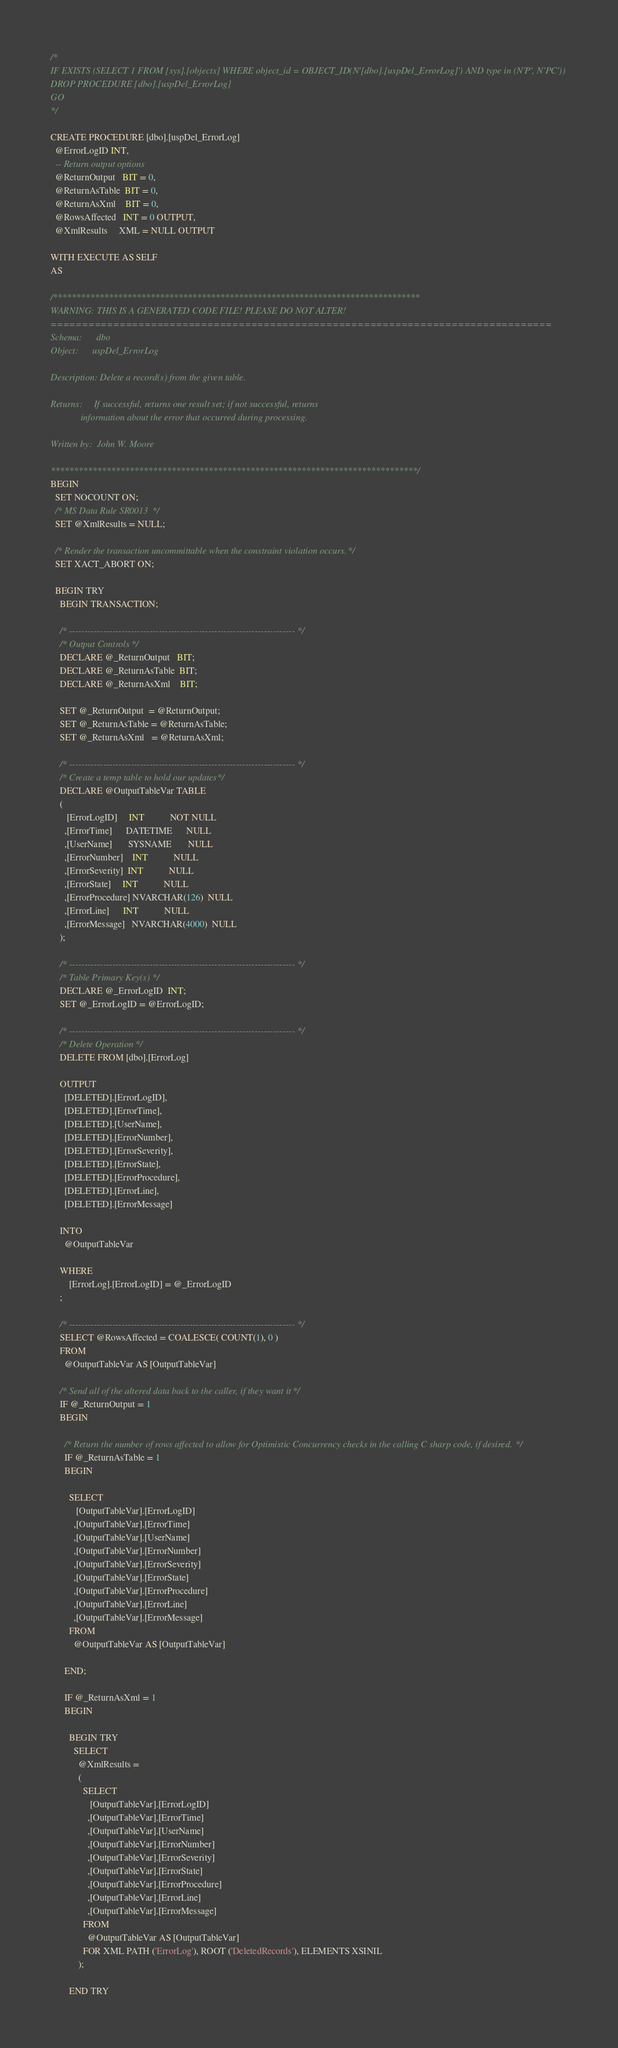Convert code to text. <code><loc_0><loc_0><loc_500><loc_500><_SQL_>/*
IF EXISTS (SELECT 1 FROM [sys].[objects] WHERE object_id = OBJECT_ID(N'[dbo].[uspDel_ErrorLog]') AND type in (N'P', N'PC'))
DROP PROCEDURE [dbo].[uspDel_ErrorLog]
GO
*/

CREATE PROCEDURE [dbo].[uspDel_ErrorLog]
  @ErrorLogID INT,
  -- Return output options
  @ReturnOutput   BIT = 0,
  @ReturnAsTable  BIT = 0,
  @ReturnAsXml    BIT = 0,
  @RowsAffected   INT = 0 OUTPUT,
  @XmlResults     XML = NULL OUTPUT

WITH EXECUTE AS SELF
AS

/*******************************************************************************
WARNING: THIS IS A GENERATED CODE FILE! PLEASE DO NOT ALTER!
================================================================================
Schema:      dbo
Object:      uspDel_ErrorLog

Description: Delete a record(s) from the given table.

Returns:     If successful, returns one result set; if not successful, returns
             information about the error that occurred during processing.

Written by:  John W. Moore

*******************************************************************************/
BEGIN
  SET NOCOUNT ON;
  /* MS Data Rule SR0013 */
  SET @XmlResults = NULL;

  /* Render the transaction uncommittable when the constraint violation occurs. */
  SET XACT_ABORT ON;

  BEGIN TRY
    BEGIN TRANSACTION;

    /* ------------------------------------------------------------------------- */
    /* Output Controls */
    DECLARE @_ReturnOutput   BIT;
    DECLARE @_ReturnAsTable  BIT;
    DECLARE @_ReturnAsXml    BIT;

    SET @_ReturnOutput  = @ReturnOutput;
    SET @_ReturnAsTable = @ReturnAsTable;
    SET @_ReturnAsXml   = @ReturnAsXml;

    /* ------------------------------------------------------------------------- */
    /* Create a temp table to hold our updates */
    DECLARE @OutputTableVar TABLE
    (
       [ErrorLogID]     INT           NOT NULL
      ,[ErrorTime]      DATETIME      NULL
      ,[UserName]       SYSNAME       NULL
      ,[ErrorNumber]    INT           NULL
      ,[ErrorSeverity]  INT           NULL
      ,[ErrorState]     INT           NULL
      ,[ErrorProcedure] NVARCHAR(126)  NULL
      ,[ErrorLine]      INT           NULL
      ,[ErrorMessage]   NVARCHAR(4000)  NULL
    );

    /* ------------------------------------------------------------------------- */
    /* Table Primary Key(s) */
    DECLARE @_ErrorLogID  INT;
    SET @_ErrorLogID = @ErrorLogID;

    /* ------------------------------------------------------------------------- */
    /* Delete Operation */
    DELETE FROM [dbo].[ErrorLog]

    OUTPUT
      [DELETED].[ErrorLogID],
      [DELETED].[ErrorTime],
      [DELETED].[UserName],
      [DELETED].[ErrorNumber],
      [DELETED].[ErrorSeverity],
      [DELETED].[ErrorState],
      [DELETED].[ErrorProcedure],
      [DELETED].[ErrorLine],
      [DELETED].[ErrorMessage]

    INTO
      @OutputTableVar

    WHERE
        [ErrorLog].[ErrorLogID] = @_ErrorLogID
    ;

    /* ------------------------------------------------------------------------- */
    SELECT @RowsAffected = COALESCE( COUNT(1), 0 )
    FROM
      @OutputTableVar AS [OutputTableVar]

    /* Send all of the altered data back to the caller, if they want it */
    IF @_ReturnOutput = 1
    BEGIN

      /* Return the number of rows affected to allow for Optimistic Concurrency checks in the calling C sharp code, if desired. */
      IF @_ReturnAsTable = 1
      BEGIN

        SELECT
           [OutputTableVar].[ErrorLogID]
          ,[OutputTableVar].[ErrorTime]
          ,[OutputTableVar].[UserName]
          ,[OutputTableVar].[ErrorNumber]
          ,[OutputTableVar].[ErrorSeverity]
          ,[OutputTableVar].[ErrorState]
          ,[OutputTableVar].[ErrorProcedure]
          ,[OutputTableVar].[ErrorLine]
          ,[OutputTableVar].[ErrorMessage]
        FROM
          @OutputTableVar AS [OutputTableVar]

      END;

      IF @_ReturnAsXml = 1
      BEGIN

        BEGIN TRY
          SELECT
            @XmlResults =
            (
              SELECT
                 [OutputTableVar].[ErrorLogID]
                ,[OutputTableVar].[ErrorTime]
                ,[OutputTableVar].[UserName]
                ,[OutputTableVar].[ErrorNumber]
                ,[OutputTableVar].[ErrorSeverity]
                ,[OutputTableVar].[ErrorState]
                ,[OutputTableVar].[ErrorProcedure]
                ,[OutputTableVar].[ErrorLine]
                ,[OutputTableVar].[ErrorMessage]
              FROM
                @OutputTableVar AS [OutputTableVar]
              FOR XML PATH ('ErrorLog'), ROOT ('DeletedRecords'), ELEMENTS XSINIL
            );

        END TRY
</code> 